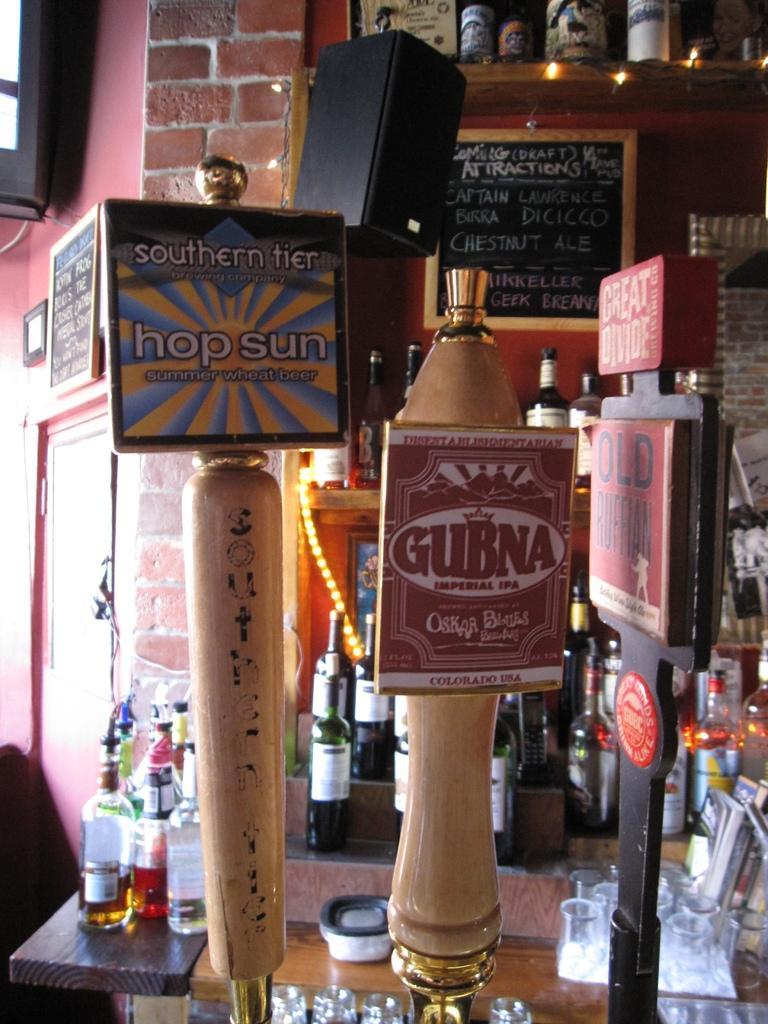Please provide a concise description of this image. On this table there is a box, glasses, books and bottles. This rack is also filled with bottles. A blackboard on wall. Beside this rock there is a speaker. Front to this three poles there are boards. 